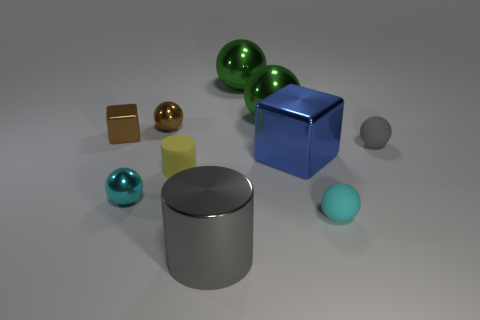Can you tell me the primary material textures represented in this image? Certainly, the image showcases objects with a variety of textures. The large gray and tiny yellow objects have a matte finish reminiscent of solid plastics or metals. The spheres and the turquoise cylinder appear to have a reflective, likely metallic surface, while the blue cube might represent a glossy-painted object. 